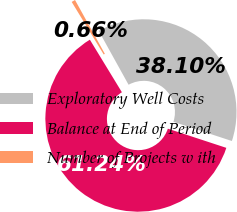<chart> <loc_0><loc_0><loc_500><loc_500><pie_chart><fcel>Exploratory Well Costs<fcel>Balance at End of Period<fcel>Number of Projects w ith<nl><fcel>38.1%<fcel>61.24%<fcel>0.66%<nl></chart> 